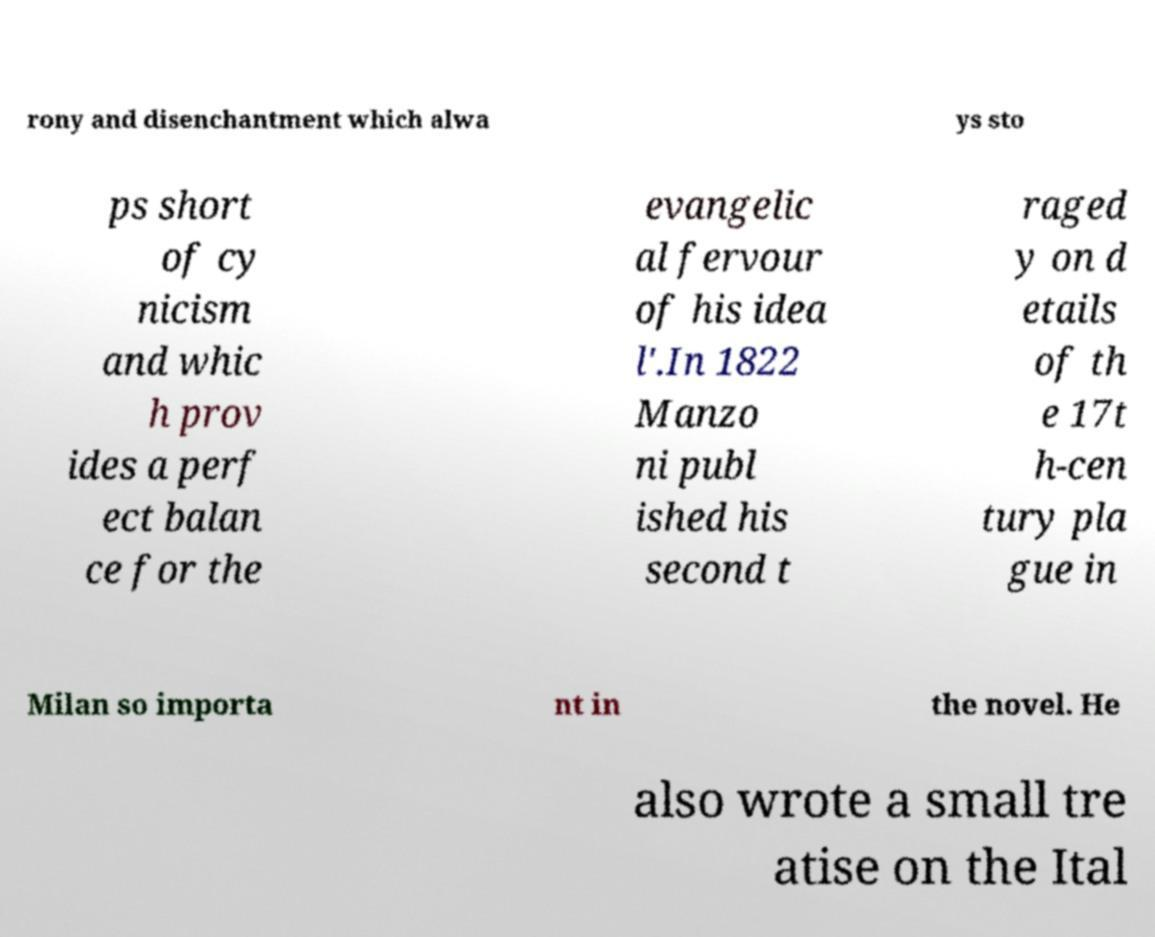For documentation purposes, I need the text within this image transcribed. Could you provide that? rony and disenchantment which alwa ys sto ps short of cy nicism and whic h prov ides a perf ect balan ce for the evangelic al fervour of his idea l'.In 1822 Manzo ni publ ished his second t raged y on d etails of th e 17t h-cen tury pla gue in Milan so importa nt in the novel. He also wrote a small tre atise on the Ital 